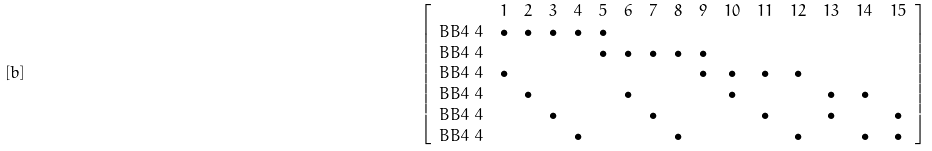Convert formula to latex. <formula><loc_0><loc_0><loc_500><loc_500>[ b ] & \quad & \left [ \begin{array} { c c c c c c c c c c c c c c c c } & 1 & 2 & 3 & 4 & 5 & 6 & 7 & 8 & 9 & 1 0 & 1 1 & 1 2 & 1 3 & 1 4 & 1 5 \\ B B 4 \ 4 & \bullet & \bullet & \bullet & \bullet & \bullet & & & & & & & & & & \\ B B 4 \ 4 & & & & & \bullet & \bullet & \bullet & \bullet & \bullet & & & & & & \\ B B 4 \ 4 & \bullet & & & & & & & & \bullet & \bullet & \bullet & \bullet & & & \\ B B 4 \ 4 & & \bullet & & & & \bullet & & & & \bullet & & & \bullet & \bullet \\ B B 4 \ 4 & & & \bullet & & & & \bullet & & & & \bullet & & \bullet & & \bullet \\ B B 4 \ 4 & & & & \bullet & & & & \bullet & & & & \bullet & & \bullet & \bullet \\ \end{array} \right ]</formula> 